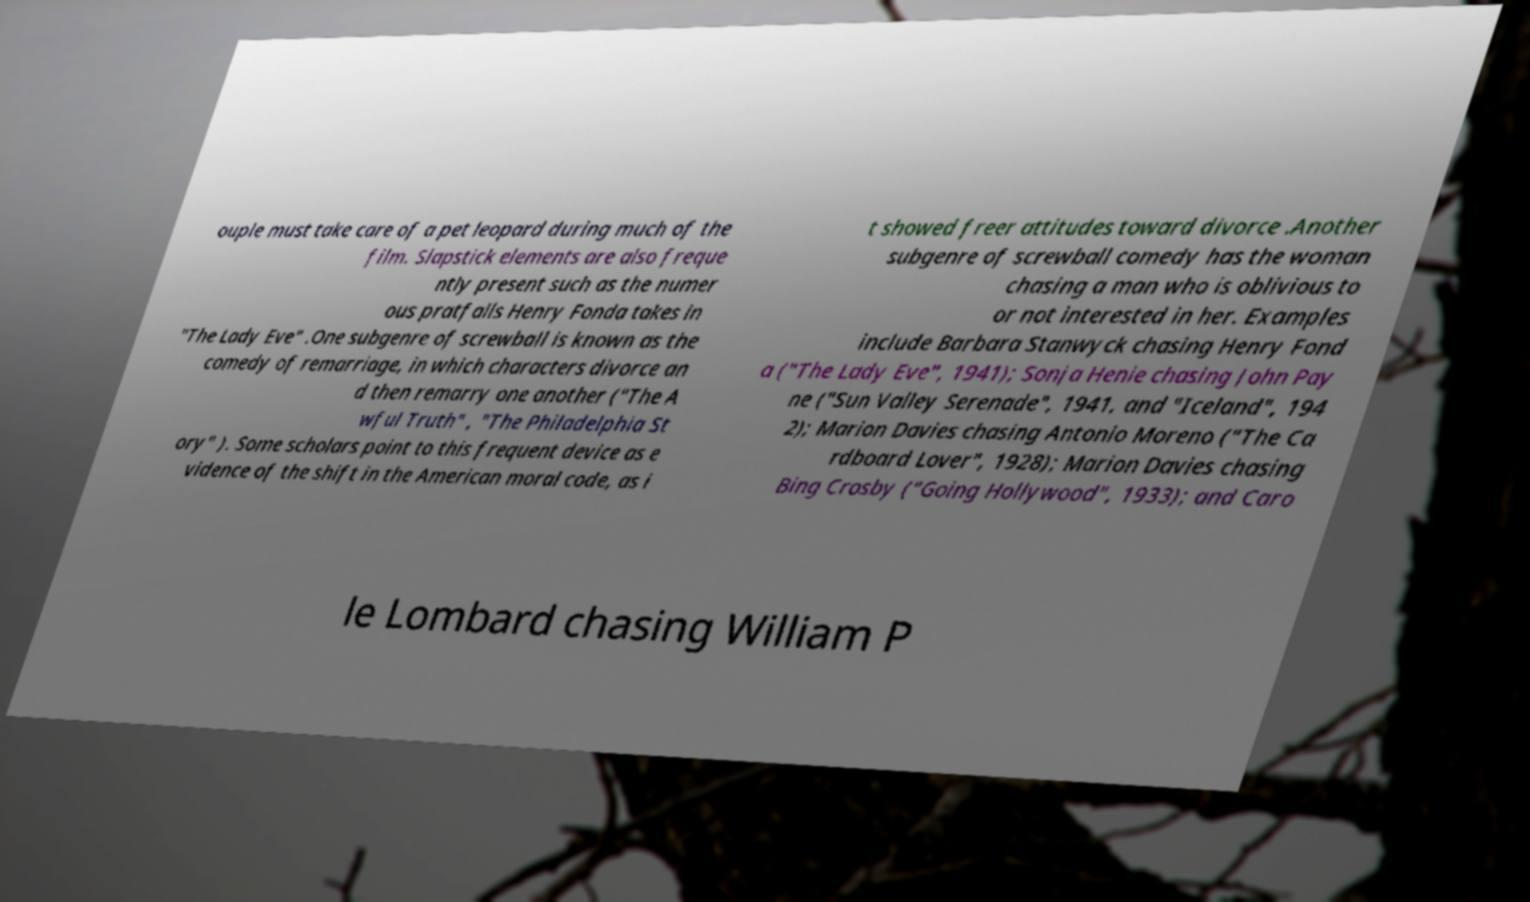Could you extract and type out the text from this image? ouple must take care of a pet leopard during much of the film. Slapstick elements are also freque ntly present such as the numer ous pratfalls Henry Fonda takes in "The Lady Eve" .One subgenre of screwball is known as the comedy of remarriage, in which characters divorce an d then remarry one another ("The A wful Truth" , "The Philadelphia St ory" ). Some scholars point to this frequent device as e vidence of the shift in the American moral code, as i t showed freer attitudes toward divorce .Another subgenre of screwball comedy has the woman chasing a man who is oblivious to or not interested in her. Examples include Barbara Stanwyck chasing Henry Fond a ("The Lady Eve", 1941); Sonja Henie chasing John Pay ne ("Sun Valley Serenade", 1941, and "Iceland", 194 2); Marion Davies chasing Antonio Moreno ("The Ca rdboard Lover", 1928); Marion Davies chasing Bing Crosby ("Going Hollywood", 1933); and Caro le Lombard chasing William P 